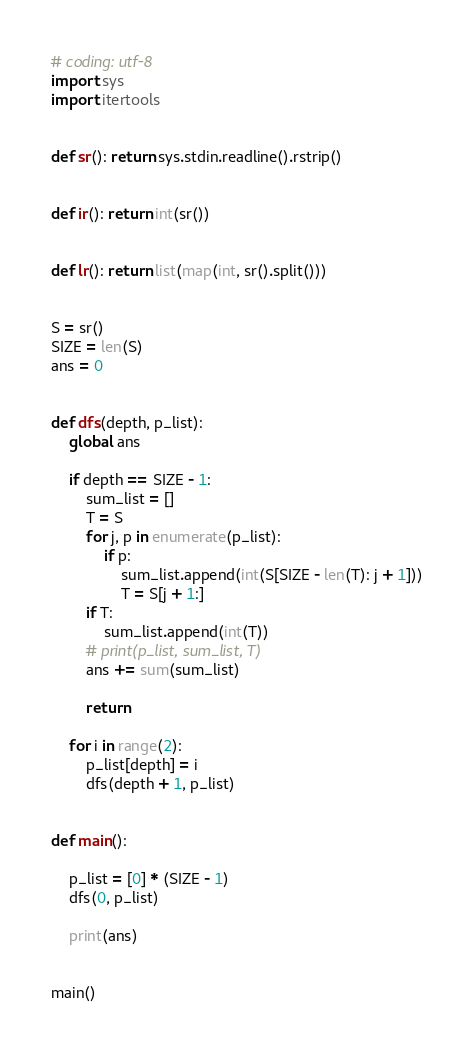<code> <loc_0><loc_0><loc_500><loc_500><_Python_># coding: utf-8
import sys
import itertools


def sr(): return sys.stdin.readline().rstrip()


def ir(): return int(sr())


def lr(): return list(map(int, sr().split()))


S = sr()
SIZE = len(S)
ans = 0


def dfs(depth, p_list):
    global ans

    if depth == SIZE - 1:
        sum_list = []
        T = S
        for j, p in enumerate(p_list):
            if p:
                sum_list.append(int(S[SIZE - len(T): j + 1]))
                T = S[j + 1:]
        if T:
            sum_list.append(int(T))
        # print(p_list, sum_list, T)
        ans += sum(sum_list)

        return

    for i in range(2):
        p_list[depth] = i
        dfs(depth + 1, p_list)


def main():

    p_list = [0] * (SIZE - 1)
    dfs(0, p_list)

    print(ans)


main()
</code> 